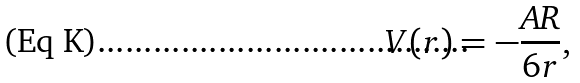Convert formula to latex. <formula><loc_0><loc_0><loc_500><loc_500>V ( r ) = - \frac { A R } { 6 r } ,</formula> 